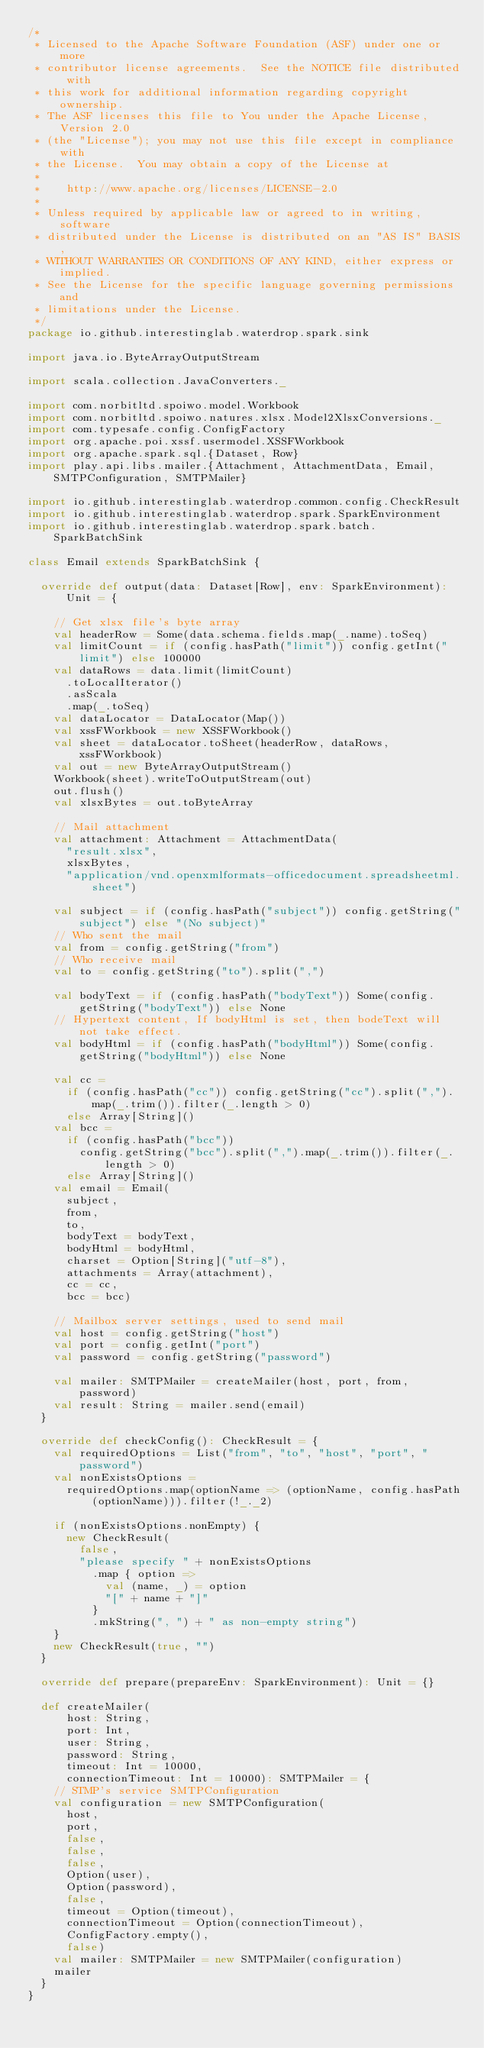Convert code to text. <code><loc_0><loc_0><loc_500><loc_500><_Scala_>/*
 * Licensed to the Apache Software Foundation (ASF) under one or more
 * contributor license agreements.  See the NOTICE file distributed with
 * this work for additional information regarding copyright ownership.
 * The ASF licenses this file to You under the Apache License, Version 2.0
 * (the "License"); you may not use this file except in compliance with
 * the License.  You may obtain a copy of the License at
 *
 *    http://www.apache.org/licenses/LICENSE-2.0
 *
 * Unless required by applicable law or agreed to in writing, software
 * distributed under the License is distributed on an "AS IS" BASIS,
 * WITHOUT WARRANTIES OR CONDITIONS OF ANY KIND, either express or implied.
 * See the License for the specific language governing permissions and
 * limitations under the License.
 */
package io.github.interestinglab.waterdrop.spark.sink

import java.io.ByteArrayOutputStream

import scala.collection.JavaConverters._

import com.norbitltd.spoiwo.model.Workbook
import com.norbitltd.spoiwo.natures.xlsx.Model2XlsxConversions._
import com.typesafe.config.ConfigFactory
import org.apache.poi.xssf.usermodel.XSSFWorkbook
import org.apache.spark.sql.{Dataset, Row}
import play.api.libs.mailer.{Attachment, AttachmentData, Email, SMTPConfiguration, SMTPMailer}

import io.github.interestinglab.waterdrop.common.config.CheckResult
import io.github.interestinglab.waterdrop.spark.SparkEnvironment
import io.github.interestinglab.waterdrop.spark.batch.SparkBatchSink

class Email extends SparkBatchSink {

  override def output(data: Dataset[Row], env: SparkEnvironment): Unit = {

    // Get xlsx file's byte array
    val headerRow = Some(data.schema.fields.map(_.name).toSeq)
    val limitCount = if (config.hasPath("limit")) config.getInt("limit") else 100000
    val dataRows = data.limit(limitCount)
      .toLocalIterator()
      .asScala
      .map(_.toSeq)
    val dataLocator = DataLocator(Map())
    val xssFWorkbook = new XSSFWorkbook()
    val sheet = dataLocator.toSheet(headerRow, dataRows, xssFWorkbook)
    val out = new ByteArrayOutputStream()
    Workbook(sheet).writeToOutputStream(out)
    out.flush()
    val xlsxBytes = out.toByteArray

    // Mail attachment
    val attachment: Attachment = AttachmentData(
      "result.xlsx",
      xlsxBytes,
      "application/vnd.openxmlformats-officedocument.spreadsheetml.sheet")

    val subject = if (config.hasPath("subject")) config.getString("subject") else "(No subject)"
    // Who sent the mail
    val from = config.getString("from")
    // Who receive mail
    val to = config.getString("to").split(",")

    val bodyText = if (config.hasPath("bodyText")) Some(config.getString("bodyText")) else None
    // Hypertext content, If bodyHtml is set, then bodeText will not take effect.
    val bodyHtml = if (config.hasPath("bodyHtml")) Some(config.getString("bodyHtml")) else None

    val cc =
      if (config.hasPath("cc")) config.getString("cc").split(",").map(_.trim()).filter(_.length > 0)
      else Array[String]()
    val bcc =
      if (config.hasPath("bcc"))
        config.getString("bcc").split(",").map(_.trim()).filter(_.length > 0)
      else Array[String]()
    val email = Email(
      subject,
      from,
      to,
      bodyText = bodyText,
      bodyHtml = bodyHtml,
      charset = Option[String]("utf-8"),
      attachments = Array(attachment),
      cc = cc,
      bcc = bcc)

    // Mailbox server settings, used to send mail
    val host = config.getString("host")
    val port = config.getInt("port")
    val password = config.getString("password")

    val mailer: SMTPMailer = createMailer(host, port, from, password)
    val result: String = mailer.send(email)
  }

  override def checkConfig(): CheckResult = {
    val requiredOptions = List("from", "to", "host", "port", "password")
    val nonExistsOptions =
      requiredOptions.map(optionName => (optionName, config.hasPath(optionName))).filter(!_._2)

    if (nonExistsOptions.nonEmpty) {
      new CheckResult(
        false,
        "please specify " + nonExistsOptions
          .map { option =>
            val (name, _) = option
            "[" + name + "]"
          }
          .mkString(", ") + " as non-empty string")
    }
    new CheckResult(true, "")
  }

  override def prepare(prepareEnv: SparkEnvironment): Unit = {}

  def createMailer(
      host: String,
      port: Int,
      user: String,
      password: String,
      timeout: Int = 10000,
      connectionTimeout: Int = 10000): SMTPMailer = {
    // STMP's service SMTPConfiguration
    val configuration = new SMTPConfiguration(
      host,
      port,
      false,
      false,
      false,
      Option(user),
      Option(password),
      false,
      timeout = Option(timeout),
      connectionTimeout = Option(connectionTimeout),
      ConfigFactory.empty(),
      false)
    val mailer: SMTPMailer = new SMTPMailer(configuration)
    mailer
  }
}
</code> 